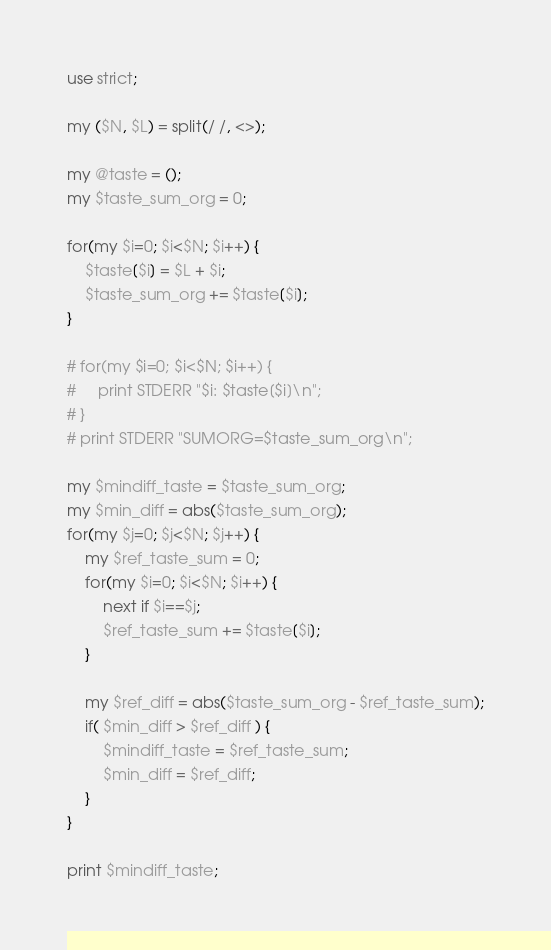Convert code to text. <code><loc_0><loc_0><loc_500><loc_500><_Perl_>use strict;

my ($N, $L) = split(/ /, <>);

my @taste = ();
my $taste_sum_org = 0;

for(my $i=0; $i<$N; $i++) {
    $taste[$i] = $L + $i;
    $taste_sum_org += $taste[$i];
}

# for(my $i=0; $i<$N; $i++) {
#     print STDERR "$i: $taste[$i]\n";
# }
# print STDERR "SUMORG=$taste_sum_org\n";

my $mindiff_taste = $taste_sum_org;
my $min_diff = abs($taste_sum_org);
for(my $j=0; $j<$N; $j++) {
    my $ref_taste_sum = 0;
    for(my $i=0; $i<$N; $i++) {
        next if $i==$j;
        $ref_taste_sum += $taste[$i];
    }

    my $ref_diff = abs($taste_sum_org - $ref_taste_sum);
    if( $min_diff > $ref_diff ) {
        $mindiff_taste = $ref_taste_sum;
        $min_diff = $ref_diff;
    }
}

print $mindiff_taste;
</code> 